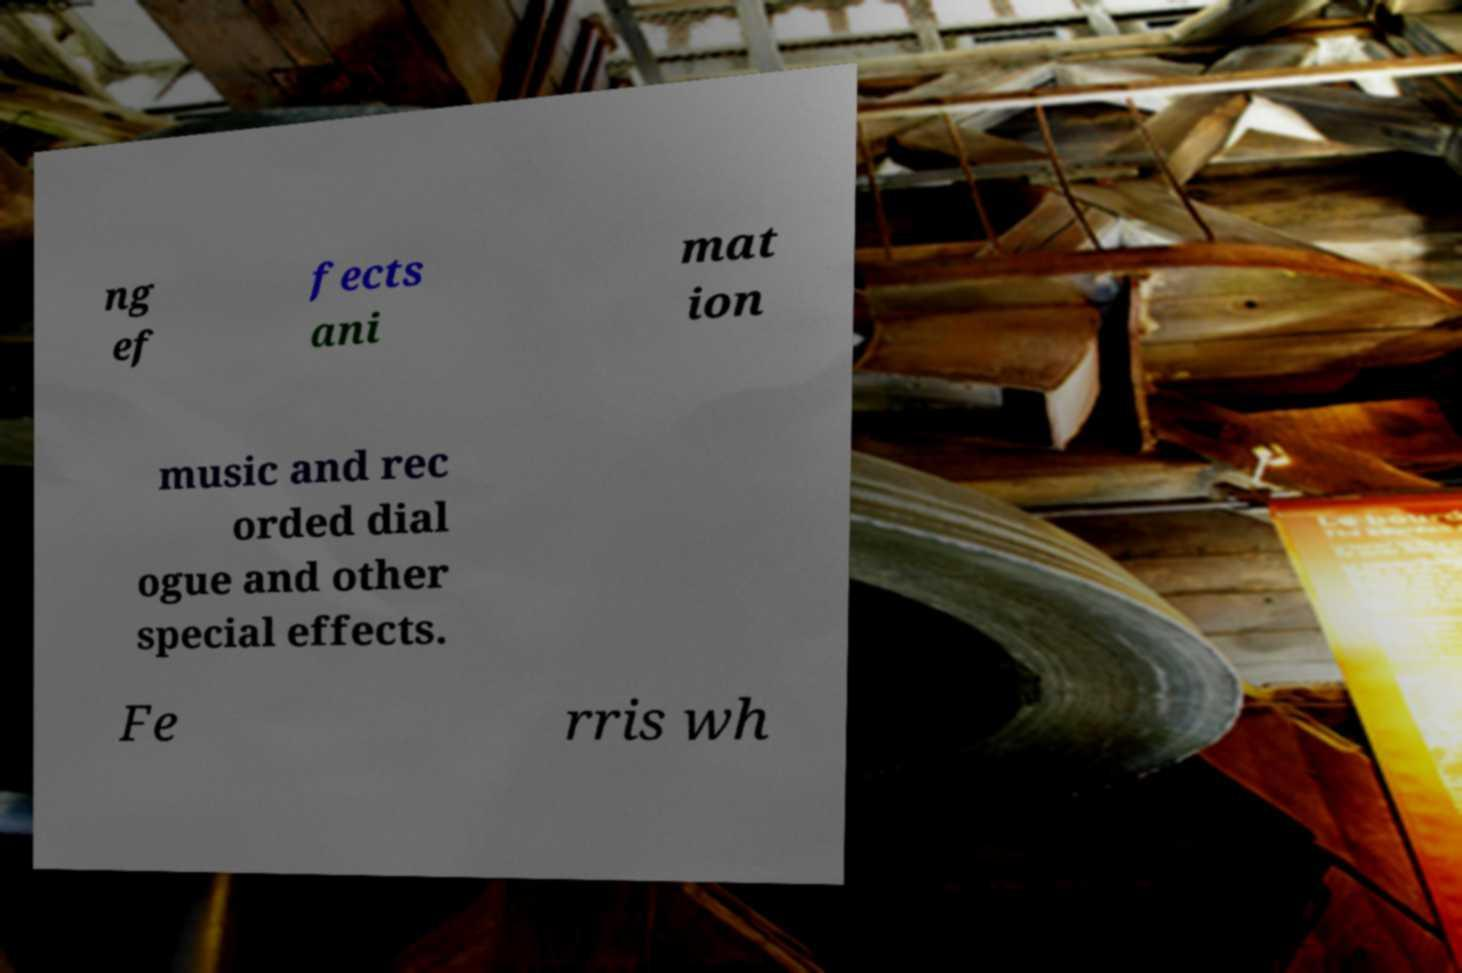There's text embedded in this image that I need extracted. Can you transcribe it verbatim? ng ef fects ani mat ion music and rec orded dial ogue and other special effects. Fe rris wh 